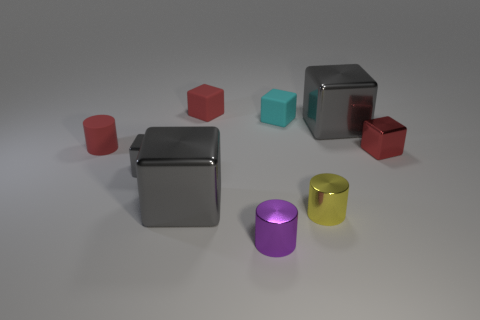The tiny shiny object that is both behind the yellow thing and on the right side of the tiny purple metallic cylinder has what shape?
Offer a very short reply. Cube. How many big things are purple blocks or gray things?
Your answer should be compact. 2. What material is the tiny purple thing?
Your response must be concise. Metal. What number of other things are the same shape as the cyan thing?
Provide a short and direct response. 5. What is the size of the red shiny block?
Give a very brief answer. Small. What size is the red thing that is in front of the tiny cyan cube and to the left of the small purple shiny cylinder?
Offer a very short reply. Small. There is a thing behind the cyan rubber thing; what is its shape?
Offer a terse response. Cube. Does the cyan object have the same material as the large block behind the tiny gray thing?
Provide a short and direct response. No. Do the tiny yellow metallic thing and the tiny purple thing have the same shape?
Your answer should be very brief. Yes. There is a purple thing that is the same shape as the tiny yellow metal object; what material is it?
Your response must be concise. Metal. 